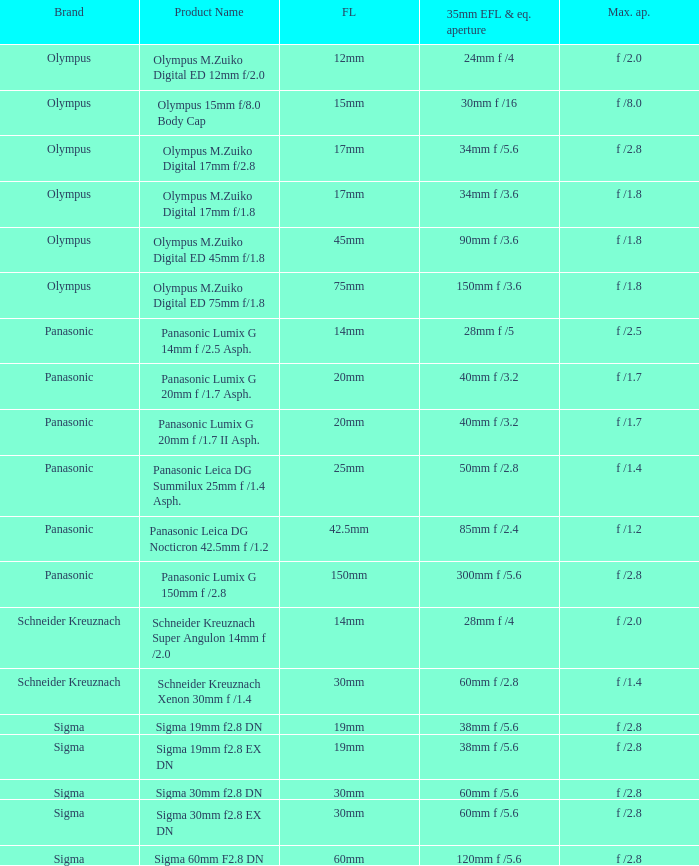What is the brand of the Sigma 30mm f2.8 DN, which has a maximum aperture of f /2.8 and a focal length of 30mm? Sigma. 